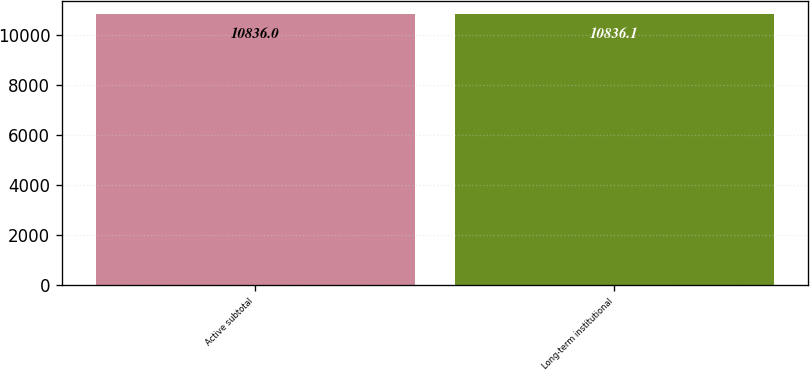Convert chart to OTSL. <chart><loc_0><loc_0><loc_500><loc_500><bar_chart><fcel>Active subtotal<fcel>Long-term institutional<nl><fcel>10836<fcel>10836.1<nl></chart> 